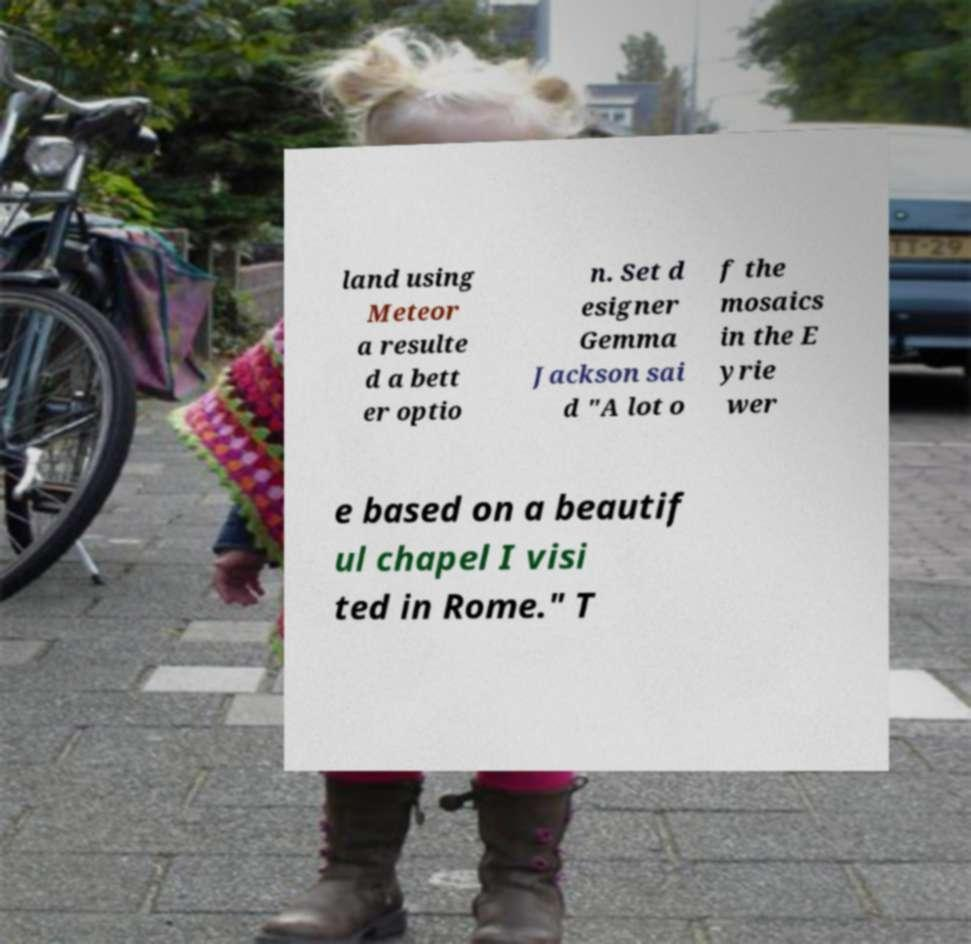Could you assist in decoding the text presented in this image and type it out clearly? land using Meteor a resulte d a bett er optio n. Set d esigner Gemma Jackson sai d "A lot o f the mosaics in the E yrie wer e based on a beautif ul chapel I visi ted in Rome." T 